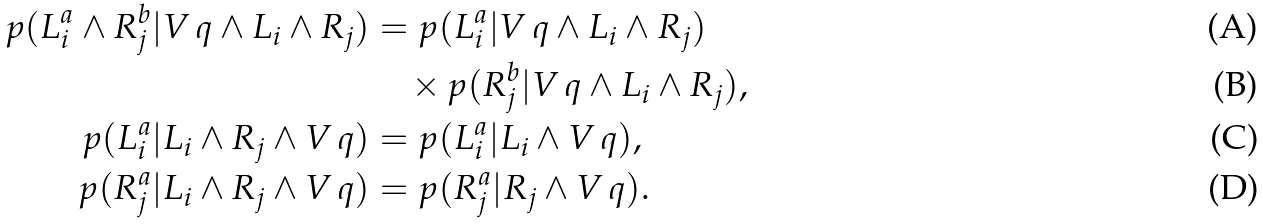<formula> <loc_0><loc_0><loc_500><loc_500>p ( L _ { i } ^ { a } \wedge R _ { j } ^ { b } | V \, q \wedge L _ { i } \wedge R _ { j } ) & = p ( L _ { i } ^ { a } | V \, q \wedge L _ { i } \wedge R _ { j } ) \\ & \quad \times p ( R _ { j } ^ { b } | V \, q \wedge L _ { i } \wedge R _ { j } ) , \\ p ( L _ { i } ^ { a } | L _ { i } \wedge R _ { j } \wedge V \, q ) & = p ( L _ { i } ^ { a } | L _ { i } \wedge V \, q ) , \\ p ( R _ { j } ^ { a } | L _ { i } \wedge R _ { j } \wedge V \, q ) & = p ( R _ { j } ^ { a } | R _ { j } \wedge V \, q ) .</formula> 